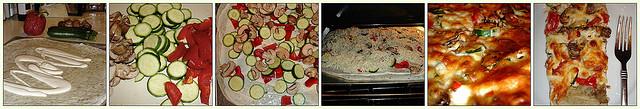What is the design in the background?
Quick response, please. Pizza. Is this showing various stages of food preparation?
Answer briefly. Yes. Is this food?
Answer briefly. Yes. How many forks are visible?
Short answer required. 1. 